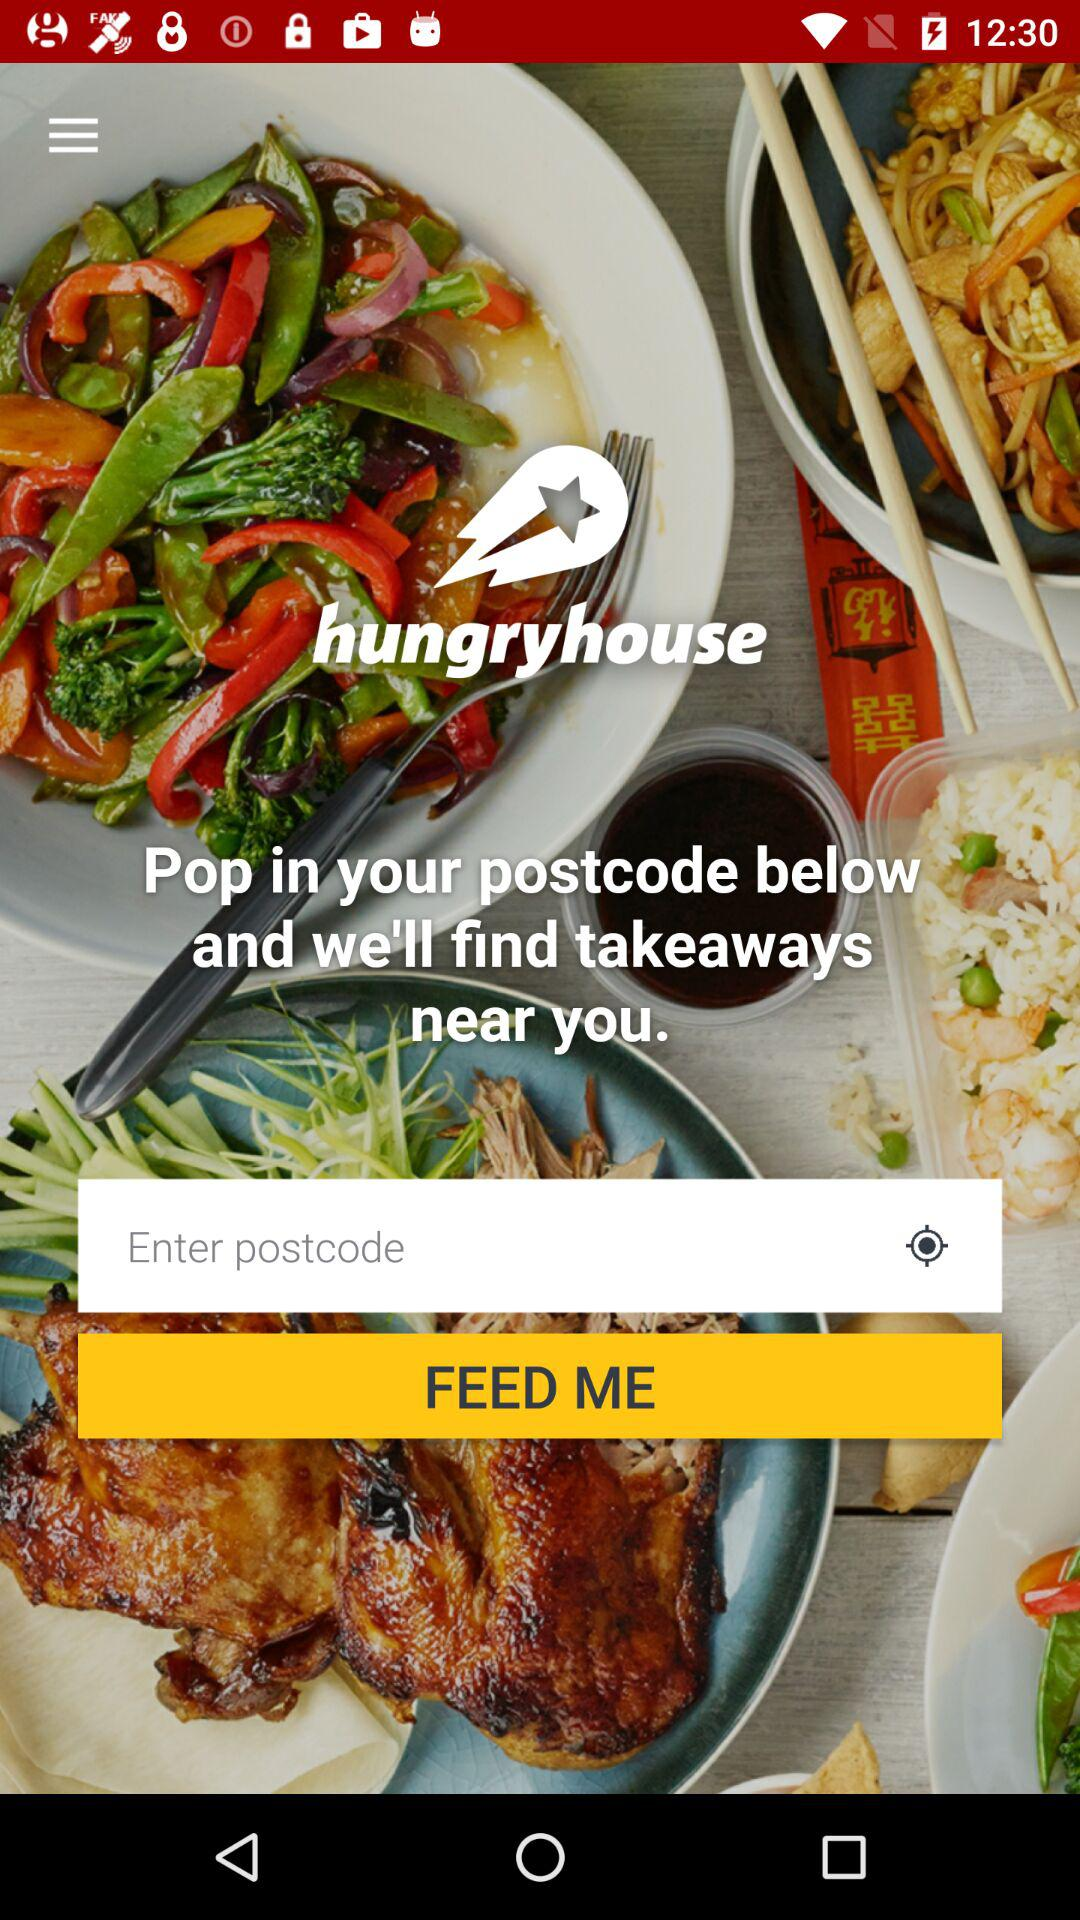What is the name of the application? The name of the application is "hungryhouse". 